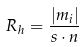Convert formula to latex. <formula><loc_0><loc_0><loc_500><loc_500>R _ { h } = \frac { | m _ { i } | } { s \cdot n }</formula> 